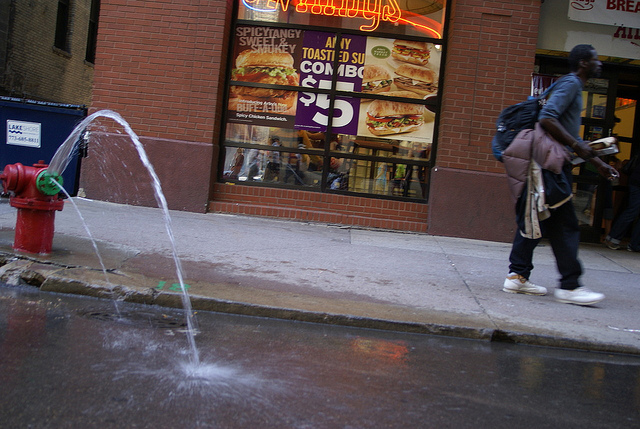Please identify all text content in this image. BREA 5 COMBO SPICY SWEET ANGY SU TOASTI 